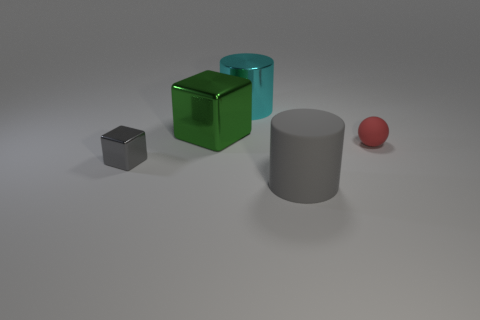Add 2 large brown things. How many objects exist? 7 Subtract all cubes. How many objects are left? 3 Add 2 big rubber things. How many big rubber things exist? 3 Subtract 0 blue blocks. How many objects are left? 5 Subtract all shiny balls. Subtract all red objects. How many objects are left? 4 Add 1 gray rubber objects. How many gray rubber objects are left? 2 